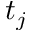<formula> <loc_0><loc_0><loc_500><loc_500>t _ { j }</formula> 